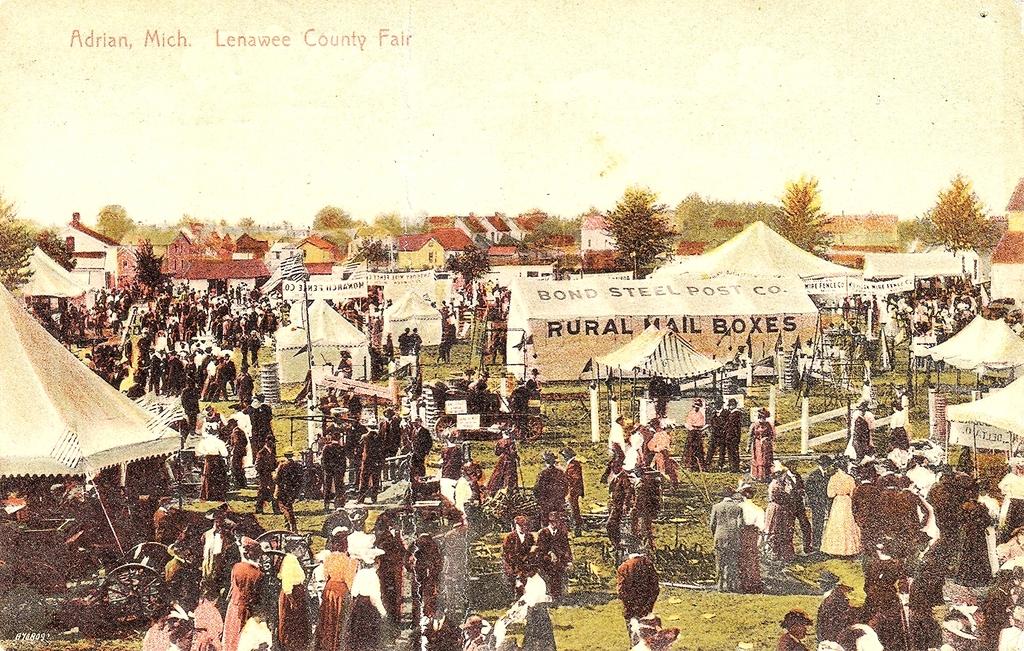Where is this image featured?
Give a very brief answer. Lenawee county fair. What kind of mail boxes does it say?
Give a very brief answer. Rural. 